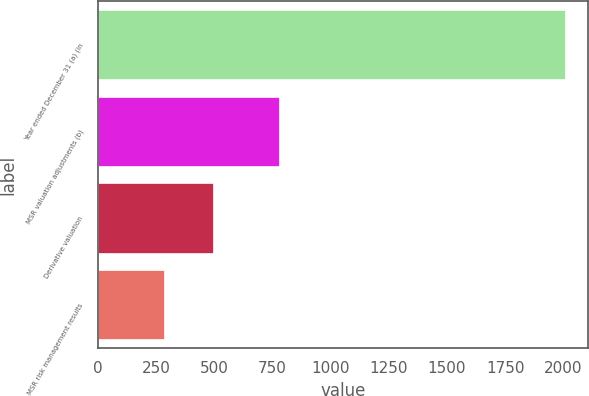Convert chart. <chart><loc_0><loc_0><loc_500><loc_500><bar_chart><fcel>Year ended December 31 (a) (in<fcel>MSR valuation adjustments (b)<fcel>Derivative valuation<fcel>MSR risk management results<nl><fcel>2005<fcel>777<fcel>494<fcel>283<nl></chart> 